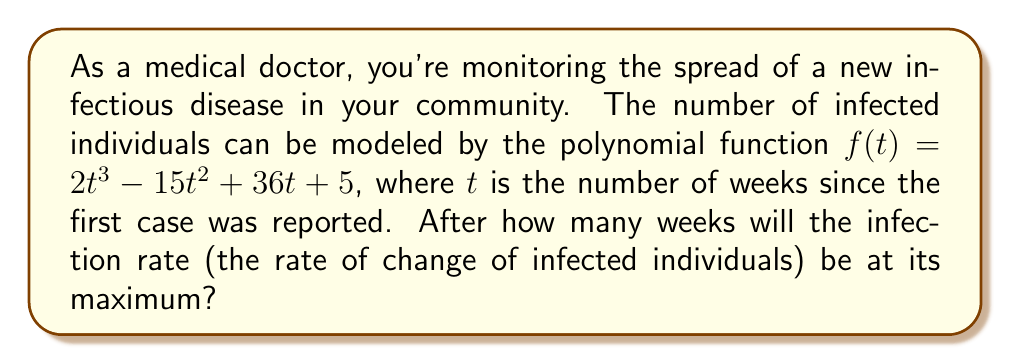Can you answer this question? To find when the infection rate is at its maximum, we need to follow these steps:

1) The infection rate is given by the first derivative of $f(t)$. Let's call this $f'(t)$.
   
   $f'(t) = 6t^2 - 30t + 36$

2) The maximum infection rate will occur when the rate of change of the infection rate (the second derivative) is zero. Let's find $f''(t)$.
   
   $f''(t) = 12t - 30$

3) Set $f''(t) = 0$ and solve for $t$:
   
   $12t - 30 = 0$
   $12t = 30$
   $t = \frac{30}{12} = 2.5$

4) To confirm this is a maximum (not a minimum), we can check that $f'''(t) = 12$ is positive.

5) Since $t$ represents weeks, we need to interpret this result in the context of the problem. The infection rate will be at its maximum 2.5 weeks after the first case was reported.
Answer: 2.5 weeks 